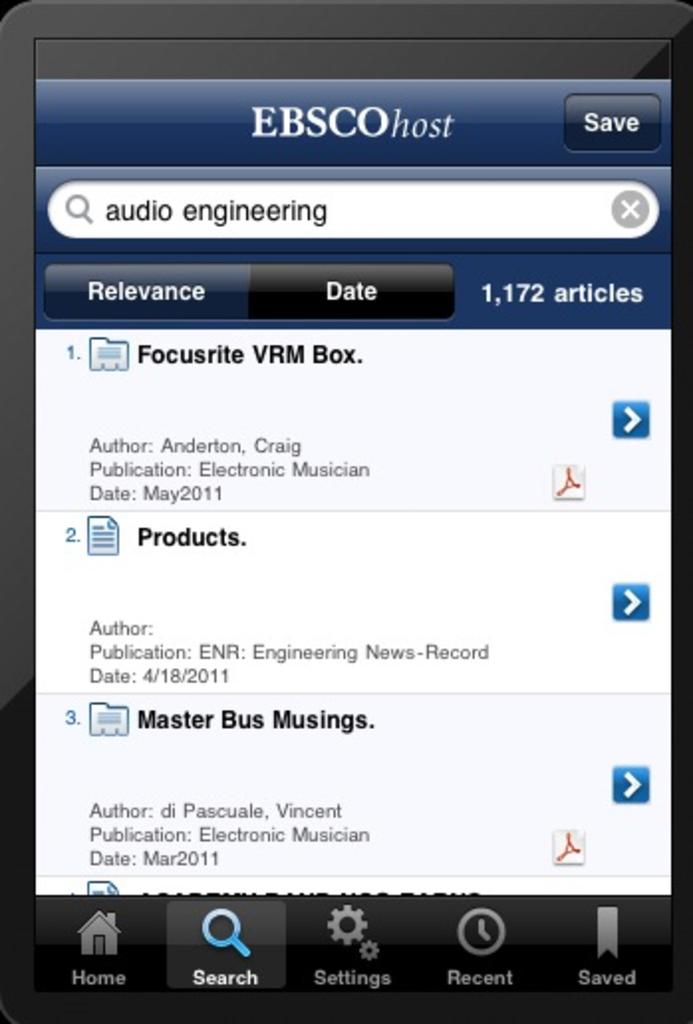What is the name of this app?
Provide a succinct answer. Ebscohost. 